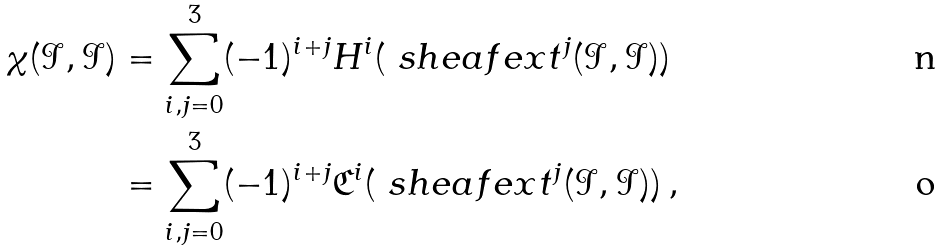<formula> <loc_0><loc_0><loc_500><loc_500>\chi ( \mathcal { I } , \mathcal { I } ) & = \sum _ { i , j = 0 } ^ { 3 } ( - 1 ) ^ { i + j } H ^ { i } ( \ s h e a f e x t ^ { j } ( \mathcal { I } , \mathcal { I } ) ) \\ & = \sum _ { i , j = 0 } ^ { 3 } ( - 1 ) ^ { i + j } \mathfrak { C } ^ { i } ( \ s h e a f e x t ^ { j } ( \mathcal { I } , \mathcal { I } ) ) \, ,</formula> 